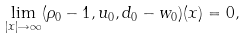Convert formula to latex. <formula><loc_0><loc_0><loc_500><loc_500>\underset { | x | \rightarrow \infty } { \lim } ( \rho _ { 0 } - 1 , u _ { 0 } , d _ { 0 } - w _ { 0 } ) ( x ) = 0 ,</formula> 